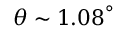<formula> <loc_0><loc_0><loc_500><loc_500>{ \theta } { \sim } 1 . { 0 8 } ^ { { \circ } }</formula> 